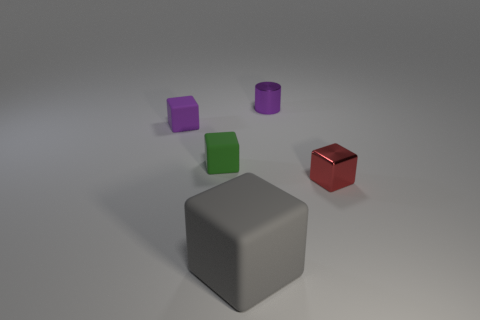The gray thing that is the same shape as the purple matte thing is what size?
Provide a short and direct response. Large. Is there any other thing that has the same material as the large gray object?
Ensure brevity in your answer.  Yes. Are there any shiny cubes?
Make the answer very short. Yes. Does the cylinder have the same color as the block to the right of the gray matte object?
Your response must be concise. No. There is a rubber block that is in front of the metallic thing that is right of the shiny thing on the left side of the tiny red shiny object; how big is it?
Provide a short and direct response. Large. What number of tiny metal cylinders have the same color as the large block?
Offer a very short reply. 0. What number of objects are tiny purple blocks or objects behind the large matte block?
Keep it short and to the point. 4. What is the color of the tiny cylinder?
Keep it short and to the point. Purple. What color is the small object that is behind the tiny purple matte block?
Provide a short and direct response. Purple. What number of cylinders are to the left of the rubber cube in front of the red object?
Your answer should be very brief. 0. 